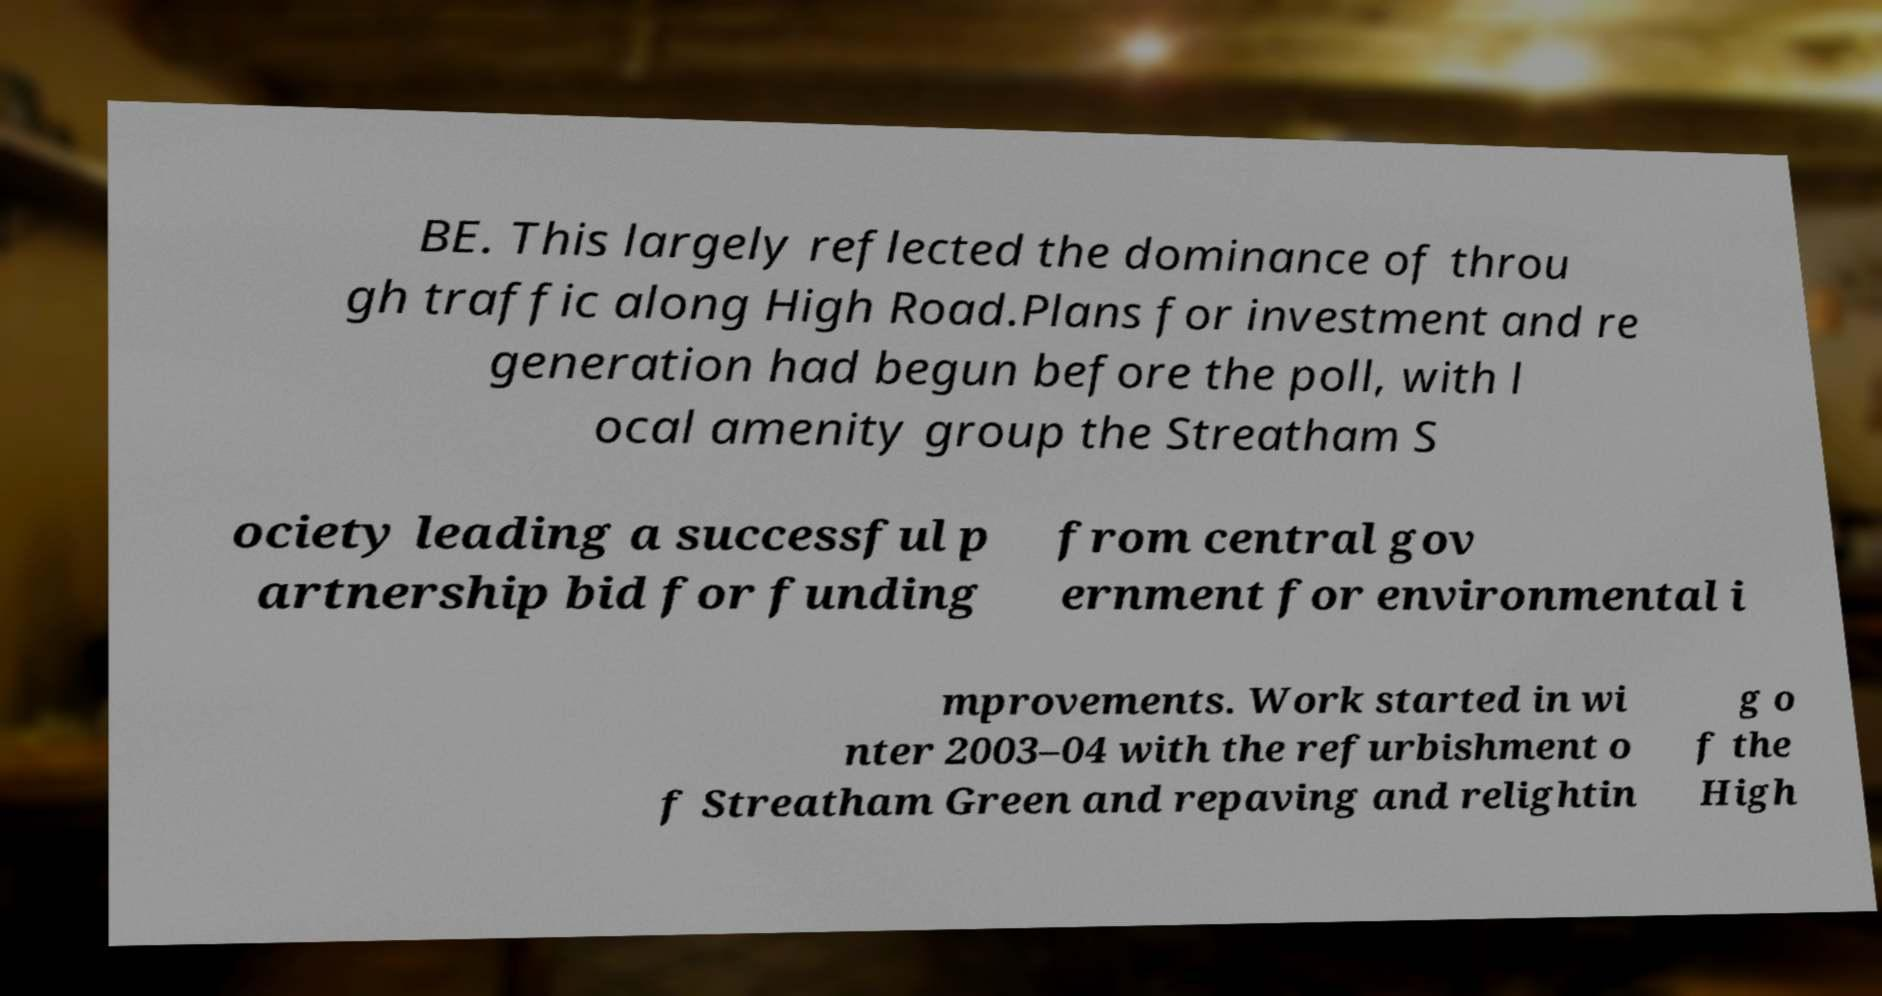Can you accurately transcribe the text from the provided image for me? BE. This largely reflected the dominance of throu gh traffic along High Road.Plans for investment and re generation had begun before the poll, with l ocal amenity group the Streatham S ociety leading a successful p artnership bid for funding from central gov ernment for environmental i mprovements. Work started in wi nter 2003–04 with the refurbishment o f Streatham Green and repaving and relightin g o f the High 